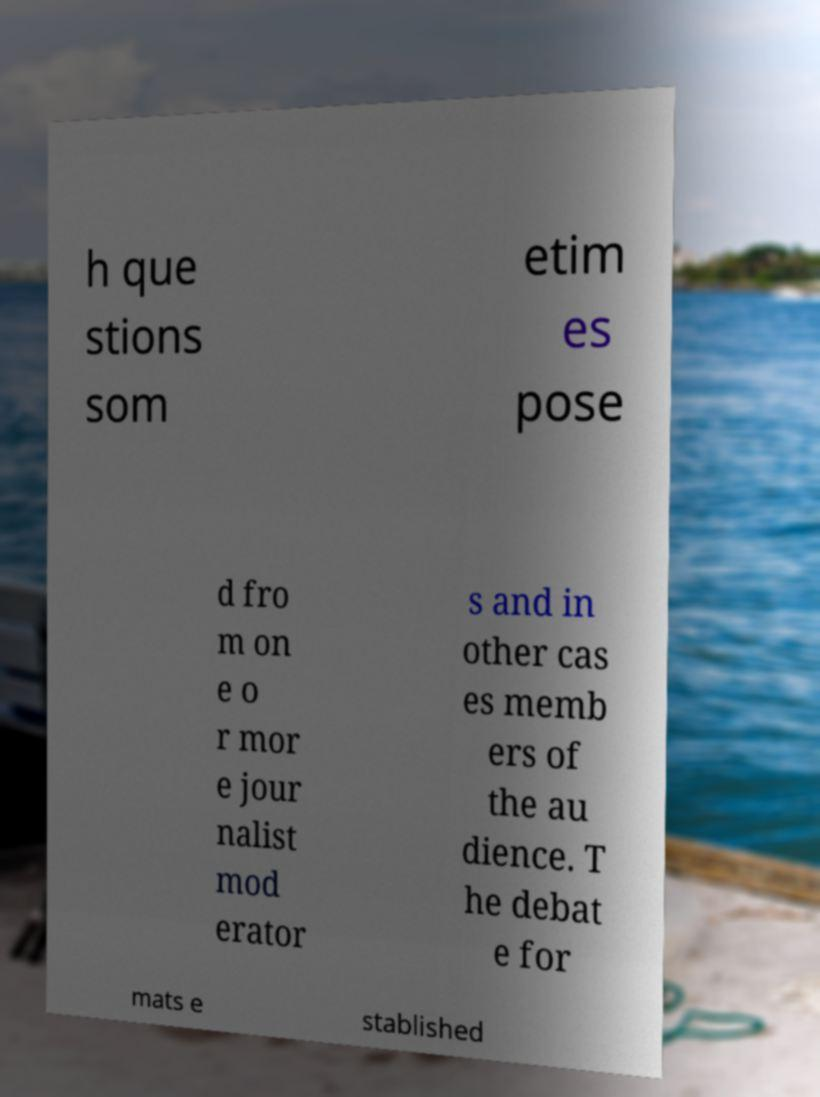Could you extract and type out the text from this image? h que stions som etim es pose d fro m on e o r mor e jour nalist mod erator s and in other cas es memb ers of the au dience. T he debat e for mats e stablished 